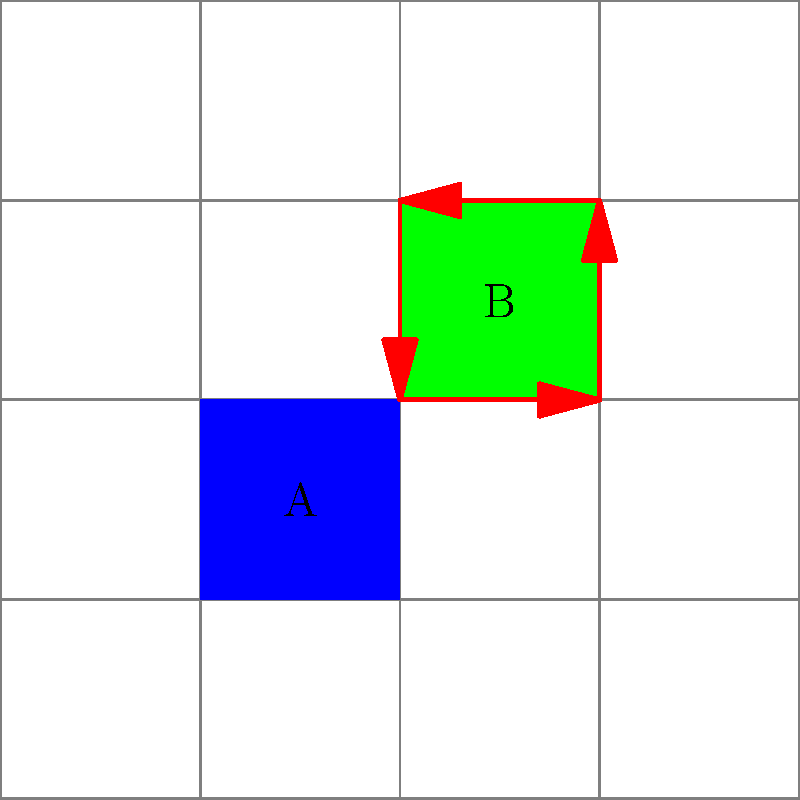In your pixel art RPG game, you have a 5x5 grid map with two important locations: a blue square (A) and a green square (B). You want to implement a rotation feature that allows the player to rotate the entire map by 90 degrees clockwise. How many 90-degree clockwise rotations are needed to return the map to its original orientation? Express your answer in terms of the order of the rotation group for this map. Let's approach this step-by-step:

1) First, we need to understand what a 90-degree clockwise rotation does to the map:
   - It moves A from (1,1) to (3,1)
   - It moves B from (2,2) to (2,3)

2) If we apply this rotation again:
   - A moves to (3,3)
   - B moves to (1,2)

3) A third rotation:
   - A moves to (1,3)
   - B moves to (1,1)

4) A fourth rotation:
   - A returns to (1,1)
   - B returns to (2,2)

5) This means that after 4 rotations, we return to the original configuration.

6) In group theory, this is equivalent to saying that the order of the rotation group for this map is 4.

7) The order of a group is the number of elements in the group. In this case, it's the number of distinct rotations (including the identity rotation) before we return to the starting position.

8) Therefore, the number of rotations needed to return to the original orientation is equal to the order of the rotation group.
Answer: 4 